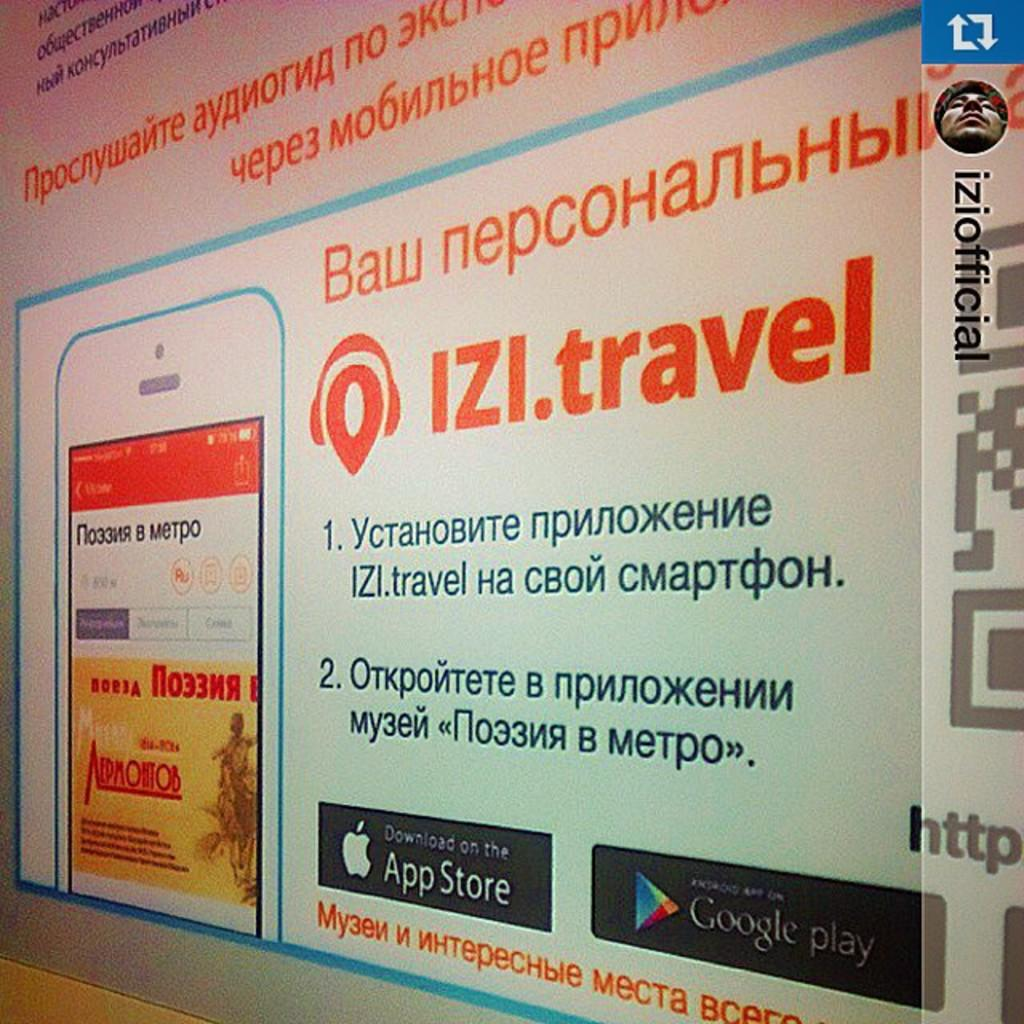<image>
Give a short and clear explanation of the subsequent image. a website design for izi.travel with app store and google play icons on the bottom 